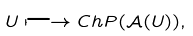<formula> <loc_0><loc_0><loc_500><loc_500>U \longmapsto C h P ( \mathcal { A } ( U ) ) ,</formula> 